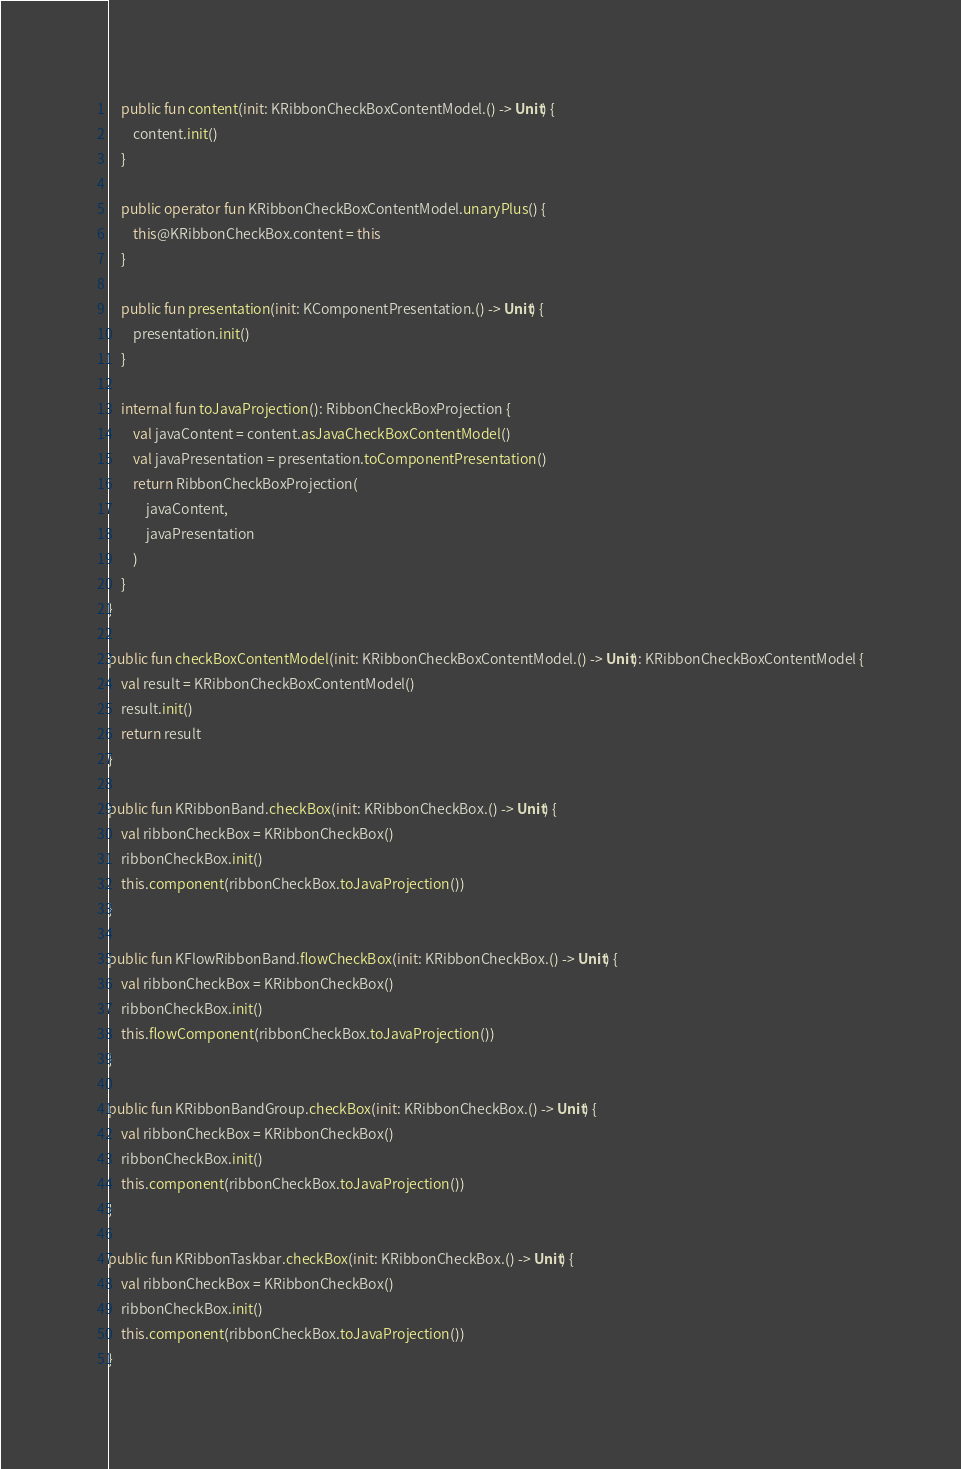Convert code to text. <code><loc_0><loc_0><loc_500><loc_500><_Kotlin_>
    public fun content(init: KRibbonCheckBoxContentModel.() -> Unit) {
        content.init()
    }

    public operator fun KRibbonCheckBoxContentModel.unaryPlus() {
        this@KRibbonCheckBox.content = this
    }

    public fun presentation(init: KComponentPresentation.() -> Unit) {
        presentation.init()
    }

    internal fun toJavaProjection(): RibbonCheckBoxProjection {
        val javaContent = content.asJavaCheckBoxContentModel()
        val javaPresentation = presentation.toComponentPresentation()
        return RibbonCheckBoxProjection(
            javaContent,
            javaPresentation
        )
    }
}

public fun checkBoxContentModel(init: KRibbonCheckBoxContentModel.() -> Unit): KRibbonCheckBoxContentModel {
    val result = KRibbonCheckBoxContentModel()
    result.init()
    return result
}

public fun KRibbonBand.checkBox(init: KRibbonCheckBox.() -> Unit) {
    val ribbonCheckBox = KRibbonCheckBox()
    ribbonCheckBox.init()
    this.component(ribbonCheckBox.toJavaProjection())
}

public fun KFlowRibbonBand.flowCheckBox(init: KRibbonCheckBox.() -> Unit) {
    val ribbonCheckBox = KRibbonCheckBox()
    ribbonCheckBox.init()
    this.flowComponent(ribbonCheckBox.toJavaProjection())
}

public fun KRibbonBandGroup.checkBox(init: KRibbonCheckBox.() -> Unit) {
    val ribbonCheckBox = KRibbonCheckBox()
    ribbonCheckBox.init()
    this.component(ribbonCheckBox.toJavaProjection())
}

public fun KRibbonTaskbar.checkBox(init: KRibbonCheckBox.() -> Unit) {
    val ribbonCheckBox = KRibbonCheckBox()
    ribbonCheckBox.init()
    this.component(ribbonCheckBox.toJavaProjection())
}


</code> 